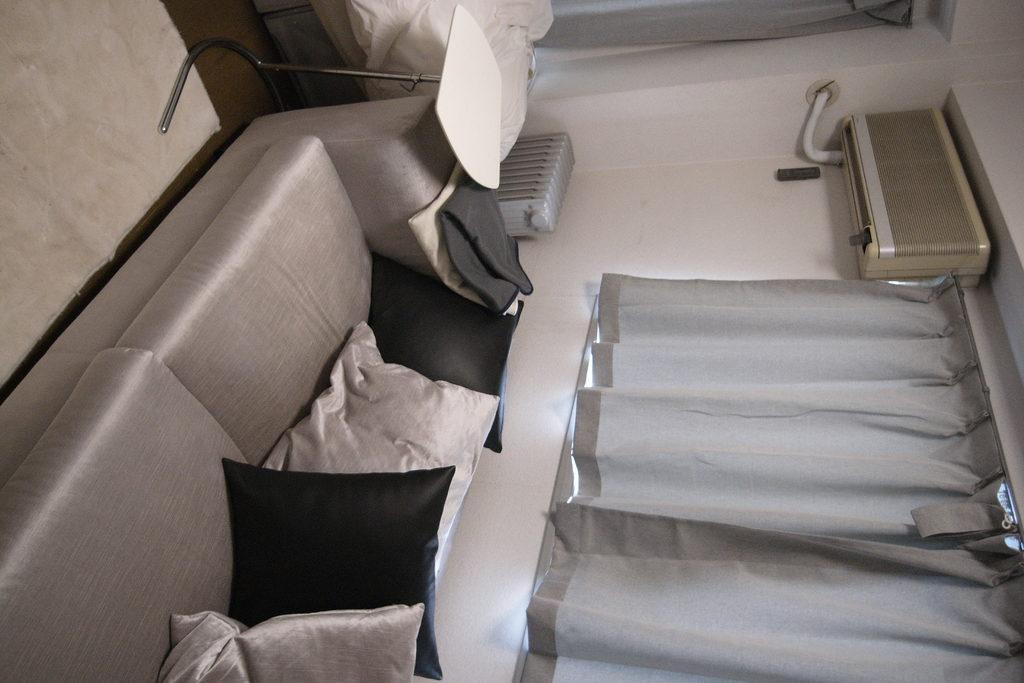How would you summarize this image in a sentence or two? In this image there is one couch on the couch there are pillows, and on the right side there is a curtain and window and air conditioner. And at the top of the image there is one stool blanket and some objects, and in the background there is a curtain and wall. On the left side of the image there is floor. 